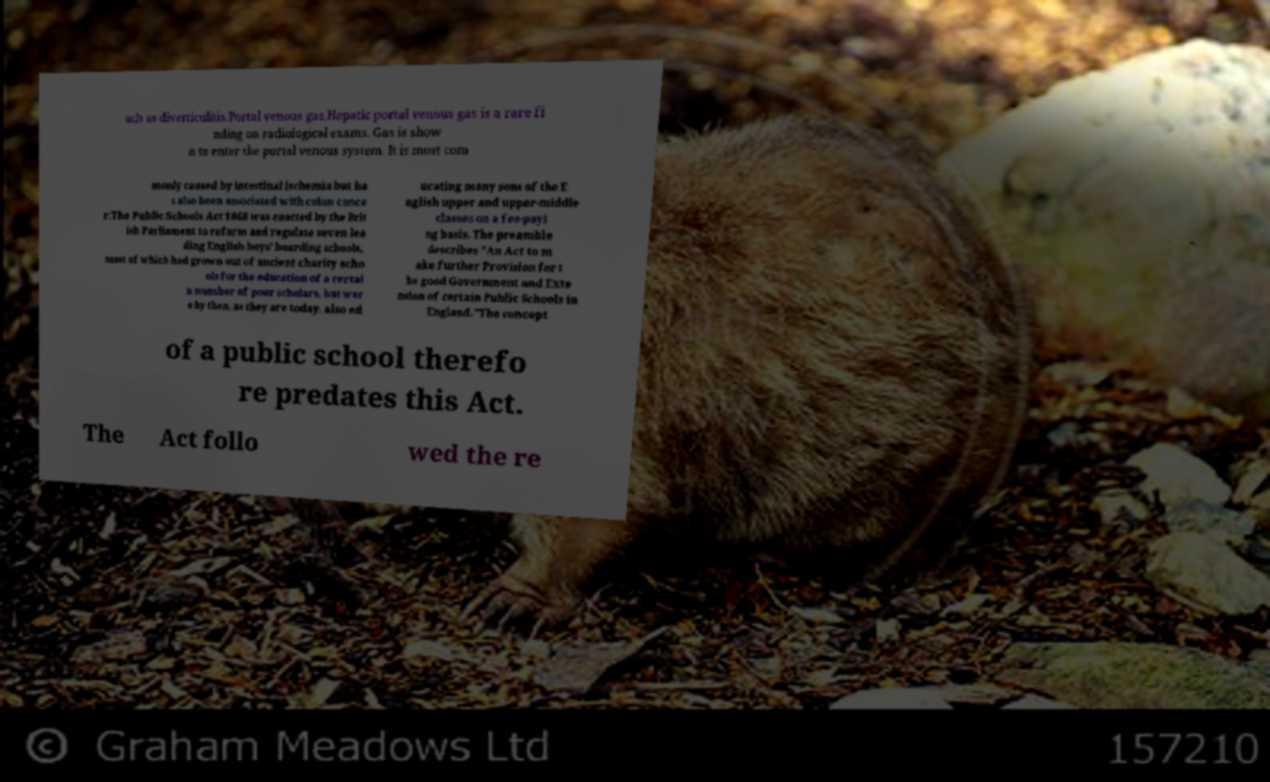Could you assist in decoding the text presented in this image and type it out clearly? uch as diverticulitis.Portal venous gas.Hepatic portal venous gas is a rare fi nding on radiological exams. Gas is show n to enter the portal venous system. It is most com monly caused by intestinal ischemia but ha s also been associated with colon cance r.The Public Schools Act 1868 was enacted by the Brit ish Parliament to reform and regulate seven lea ding English boys' boarding schools, most of which had grown out of ancient charity scho ols for the education of a certai n number of poor scholars, but wer e by then, as they are today, also ed ucating many sons of the E nglish upper and upper-middle classes on a fee-payi ng basis. The preamble describes "An Act to m ake further Provision for t he good Government and Exte nsion of certain Public Schools in England."The concept of a public school therefo re predates this Act. The Act follo wed the re 